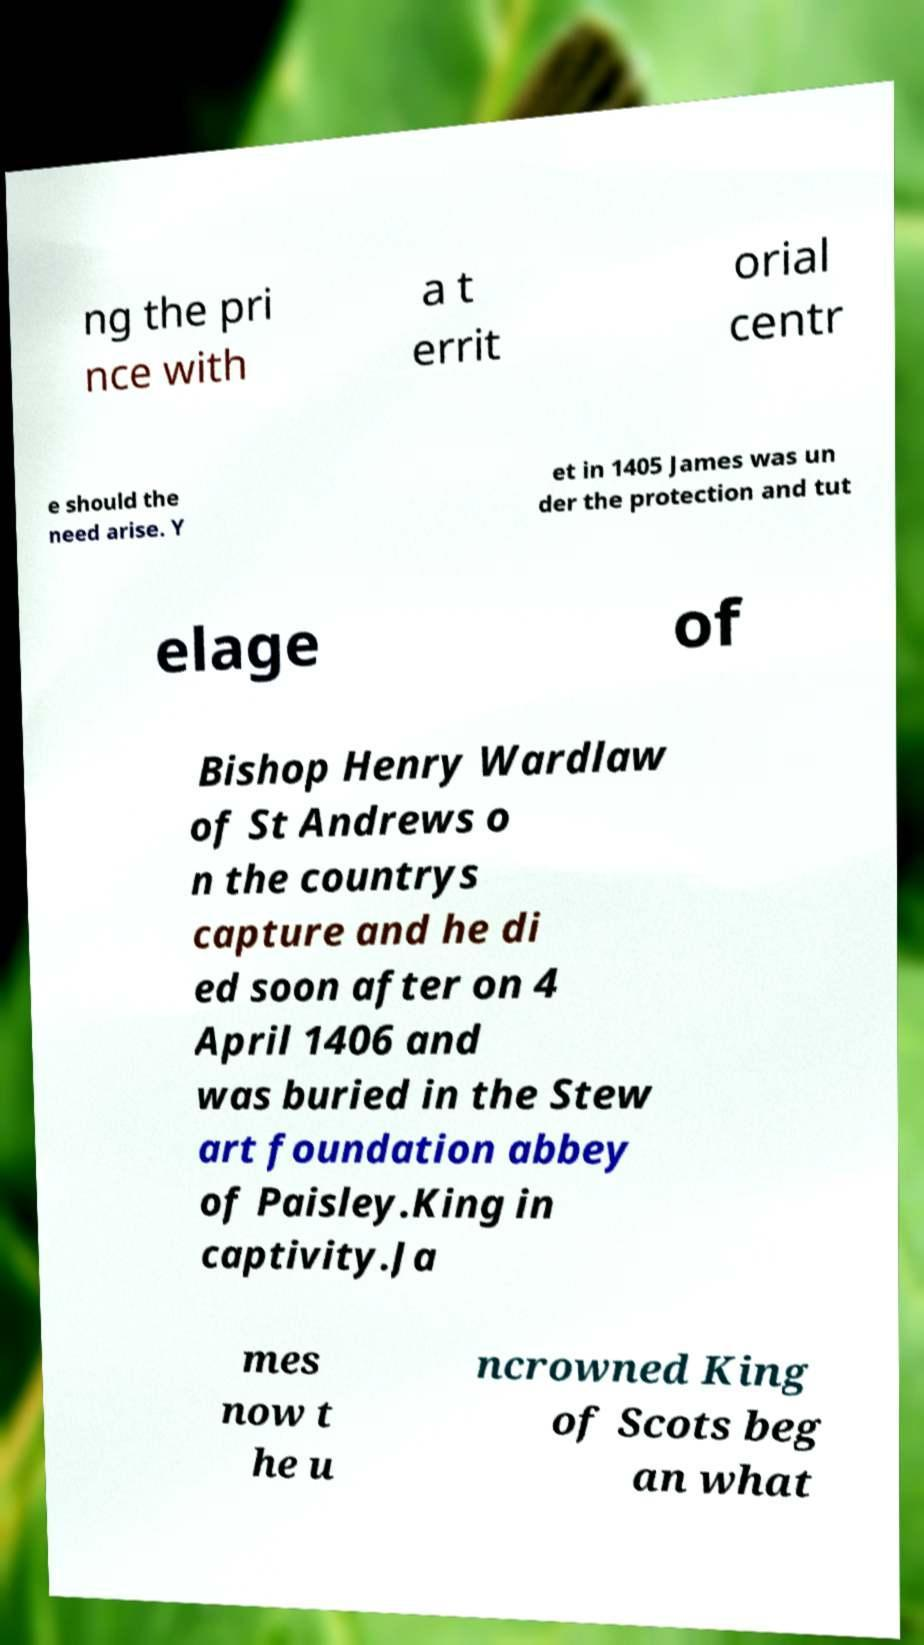There's text embedded in this image that I need extracted. Can you transcribe it verbatim? ng the pri nce with a t errit orial centr e should the need arise. Y et in 1405 James was un der the protection and tut elage of Bishop Henry Wardlaw of St Andrews o n the countrys capture and he di ed soon after on 4 April 1406 and was buried in the Stew art foundation abbey of Paisley.King in captivity.Ja mes now t he u ncrowned King of Scots beg an what 